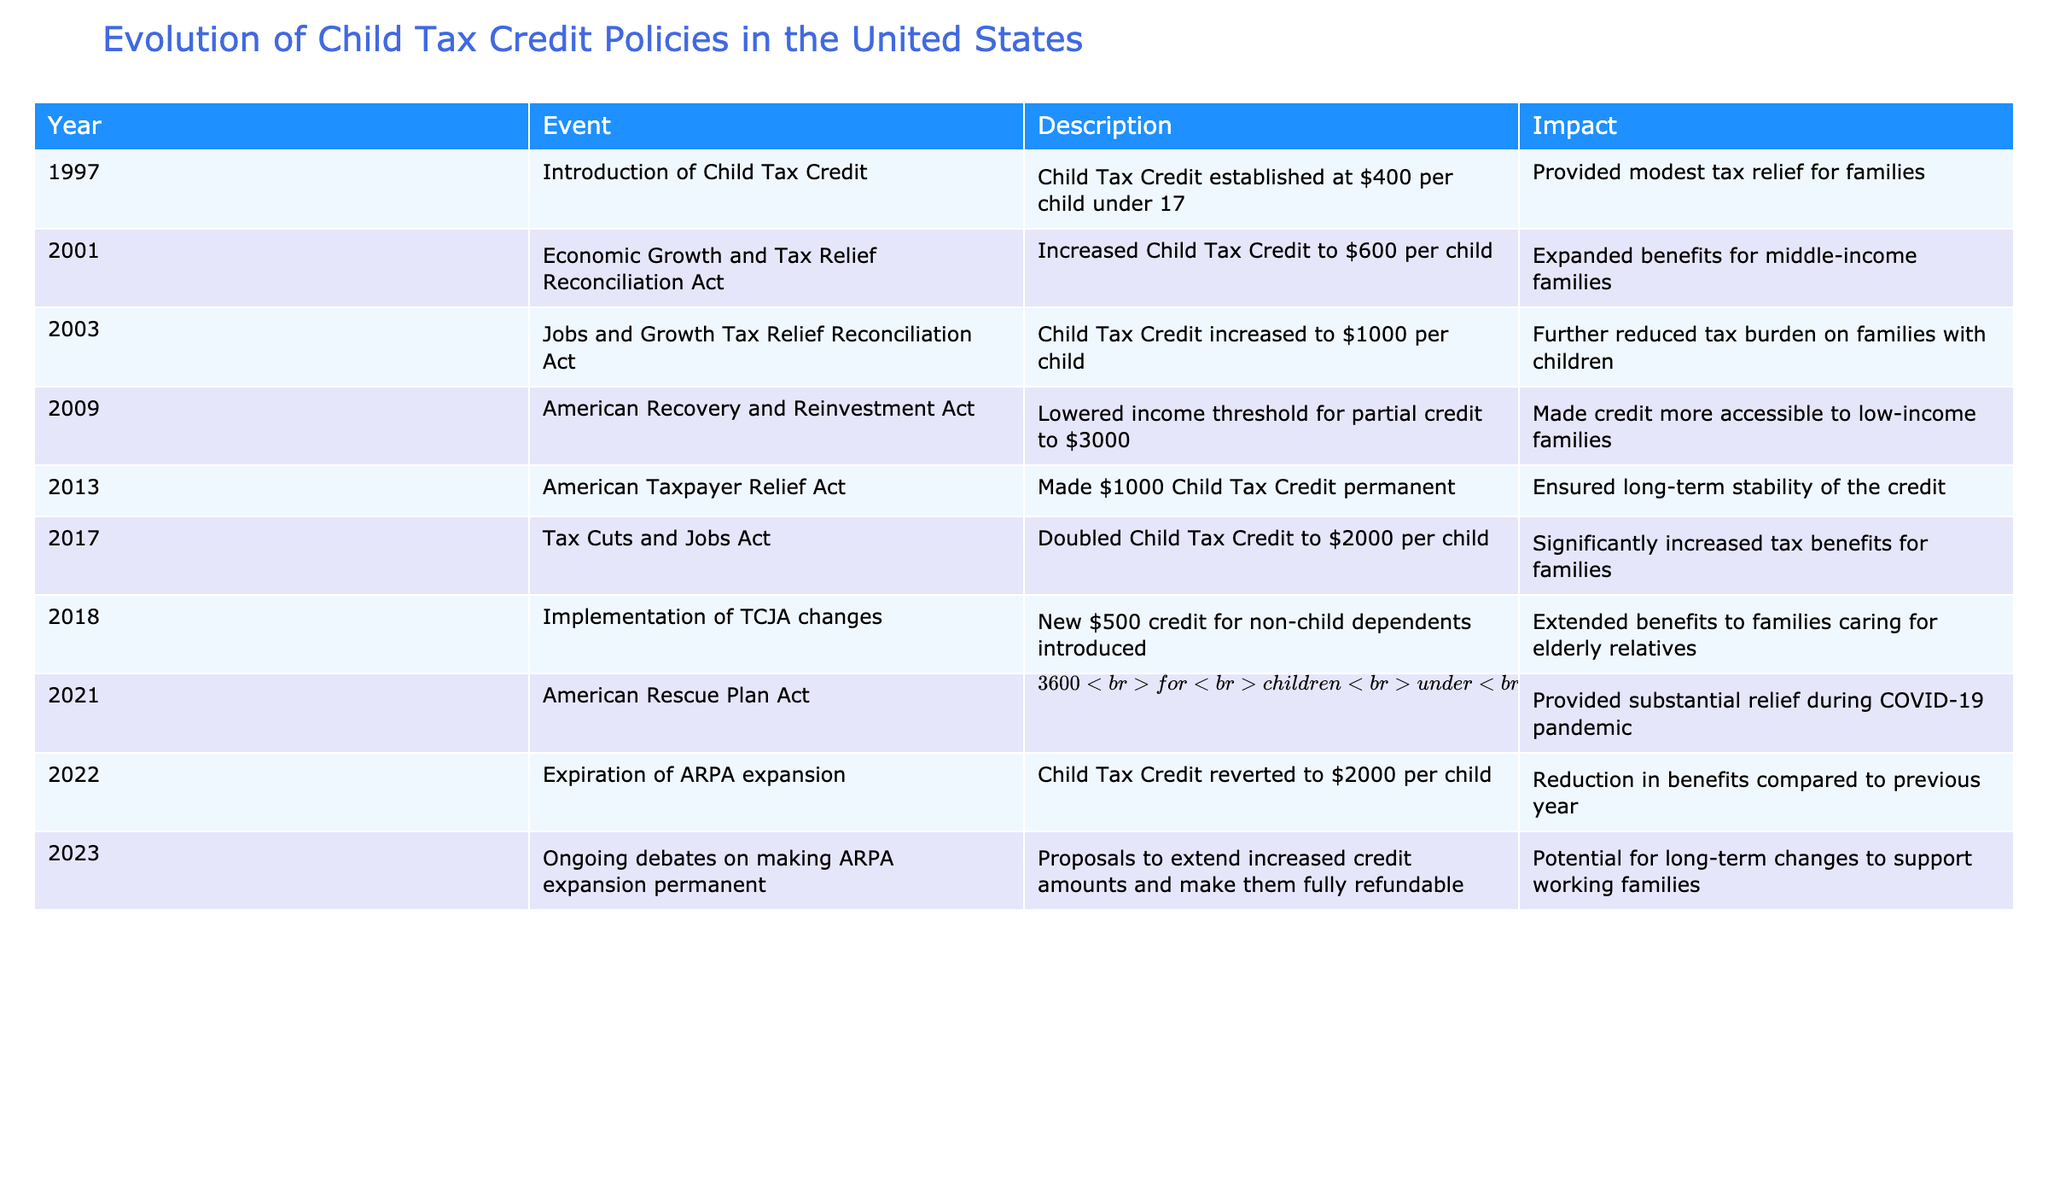What year was the Child Tax Credit introduced? The table states that the Child Tax Credit was established in 1997.
Answer: 1997 How much was the Child Tax Credit after the 2017 Tax Cuts and Jobs Act? According to the table, the Child Tax Credit was doubled to $2000 per child after the 2017 act.
Answer: $2000 What was the impact of the American Rescue Plan Act in 2021 regarding the Child Tax Credit? In 2021, the American Rescue Plan Act temporarily expanded the Child Tax Credit to $3600 for children under 6 and $3000 for children aged 6-17, as outlined in the table.
Answer: Expansion to $3600 and $3000 What was the difference in the Child Tax Credit amount in 2003 compared to 2022? In 2003, the credit was $1000 per child, and it reverted to $2000 per child in 2022. The difference is $1000 - $2000 = -$1000.
Answer: -$1000 Was the 2021 expansion of the Child Tax Credit permanent? The table indicates that the expansion provided by the American Rescue Plan Act in 2021 was temporary and expired in 2022.
Answer: No What is the total number of expansions in the Child Tax Credit amounts from 1997 to 2021? The table highlights four expansions: 1997, 2001, 2017, and 2021. Thus, the total is 4 expansions.
Answer: 4 expansions Did the American Taxpayer Relief Act of 2013 make the Child Tax Credit permanent? Yes, according to the table, the American Taxpayer Relief Act made the $1000 Child Tax Credit permanent.
Answer: Yes What was the income threshold for partial credit in 2009 after the American Recovery and Reinvestment Act? The table specifies that the income threshold was lowered to $3000 for partial credit in 2009.
Answer: $3000 